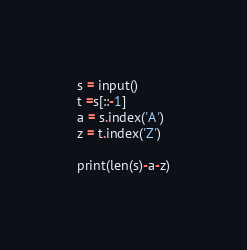Convert code to text. <code><loc_0><loc_0><loc_500><loc_500><_Python_>s = input()
t =s[::-1]
a = s.index('A')
z = t.index('Z')

print(len(s)-a-z)
</code> 